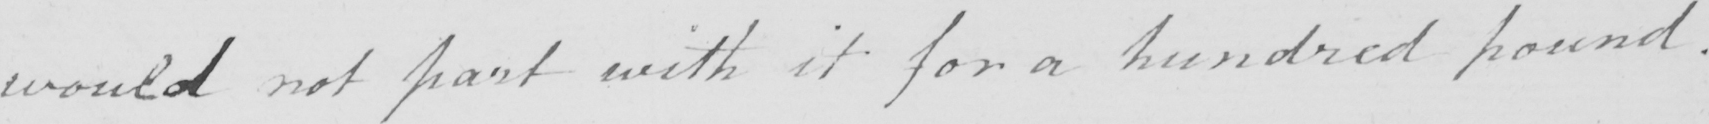What text is written in this handwritten line? would not part with it for a hundred pound . 